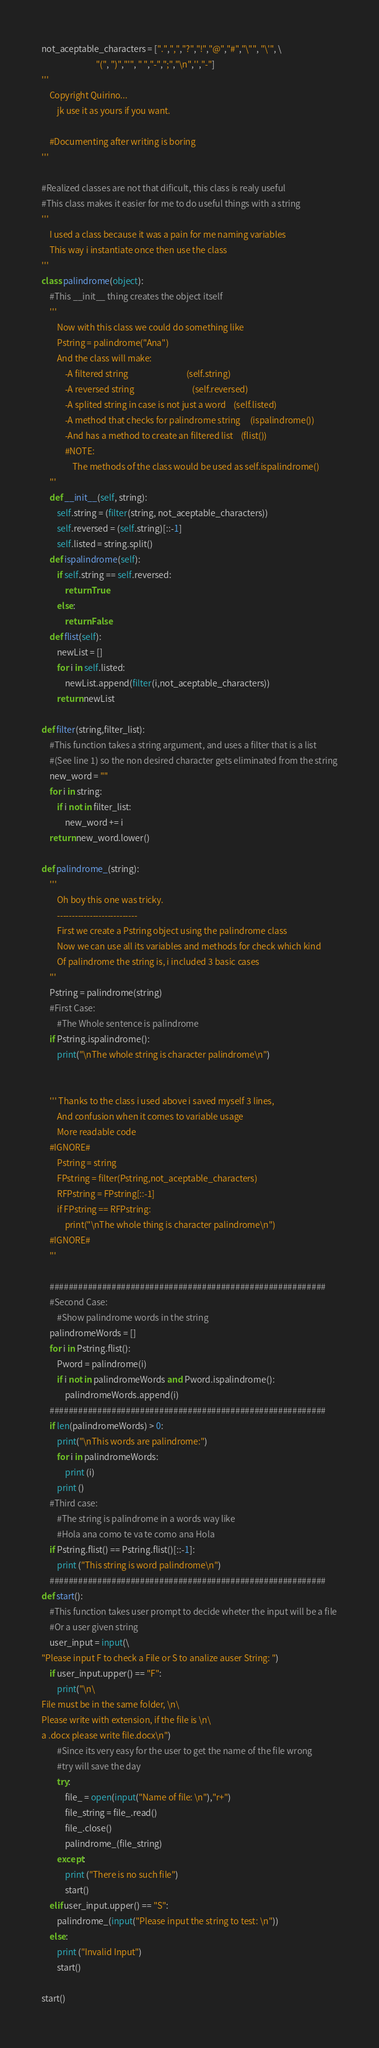<code> <loc_0><loc_0><loc_500><loc_500><_Python_>not_aceptable_characters = [".",",","?","!","@","#","\"", "\'", \
                            "(", ")","'", " ","-",";","\n",'',"-"]
'''
    Copyright Quirino...
        jk use it as yours if you want.

    #Documenting after writing is boring
'''

#Realized classes are not that dificult, this class is realy useful
#This class makes it easier for me to do useful things with a string
'''
    I used a class because it was a pain for me naming variables
    This way i instantiate once then use the class
'''
class palindrome(object):
    #This __init__ thing creates the object itself
    '''
        Now with this class we could do something like
        Pstring = palindrome("Ana")
        And the class will make:
            -A filtered string                              (self.string)
            -A reversed string                              (self.reversed)
            -A splited string in case is not just a word    (self.listed)
            -A method that checks for palindrome string     (ispalindrome())
            -And has a method to create an filtered list    (flist())
            #NOTE:
                The methods of the class would be used as self.ispalindrome()
    '''
    def __init__(self, string):
        self.string = (filter(string, not_aceptable_characters))
        self.reversed = (self.string)[::-1]
        self.listed = string.split()
    def ispalindrome(self):
        if self.string == self.reversed:
            return True
        else:
            return False
    def flist(self):
        newList = []
        for i in self.listed:
            newList.append(filter(i,not_aceptable_characters))
        return newList

def filter(string,filter_list):
    #This function takes a string argument, and uses a filter that is a list
    #(See line 1) so the non desired character gets eliminated from the string
    new_word = ""
    for i in string:
        if i not in filter_list:
            new_word += i
    return new_word.lower()

def palindrome_(string):
    '''
        Oh boy this one was tricky.
        ---------------------------
        First we create a Pstring object using the palindrome class
        Now we can use all its variables and methods for check which kind
        Of palindrome the string is, i included 3 basic cases
    '''
    Pstring = palindrome(string)
    #First Case:
        #The Whole sentence is palindrome
    if Pstring.ispalindrome():
        print("\nThe whole string is character palindrome\n")


    ''' Thanks to the class i used above i saved myself 3 lines,
        And confusion when it comes to variable usage
        More readable code
    #IGNORE#
        Pstring = string
        FPstring = filter(Pstring,not_aceptable_characters)
        RFPstring = FPstring[::-1]
        if FPstring == RFPstring:
            print("\nThe whole thing is character palindrome\n")
    #IGNORE#
    '''

    ##########################################################
    #Second Case:
        #Show palindrome words in the string
    palindromeWords = []
    for i in Pstring.flist():
        Pword = palindrome(i)
        if i not in palindromeWords and Pword.ispalindrome():
            palindromeWords.append(i)
    ##########################################################
    if len(palindromeWords) > 0:
        print("\nThis words are palindrome:")
        for i in palindromeWords:
            print (i)
        print ()
    #Third case:
        #The string is palindrome in a words way like
        #Hola ana como te va te como ana Hola
    if Pstring.flist() == Pstring.flist()[::-1]:
        print ("This string is word palindrome\n")
    ##########################################################
def start():
    #This function takes user prompt to decide wheter the input will be a file
    #Or a user given string
    user_input = input(\
"Please input F to check a File or S to analize auser String: ")
    if user_input.upper() == "F":
        print("\n\
File must be in the same folder, \n\
Please write with extension, if the file is \n\
a .docx please write file.docx\n")
        #Since its very easy for the user to get the name of the file wrong
        #try will save the day
        try:
            file_ = open(input("Name of file: \n"),"r+")
            file_string = file_.read()
            file_.close()
            palindrome_(file_string)
        except:
            print ("There is no such file")
            start()
    elif user_input.upper() == "S":
        palindrome_(input("Please input the string to test: \n"))
    else:
        print ("Invalid Input")
        start()

start()
</code> 